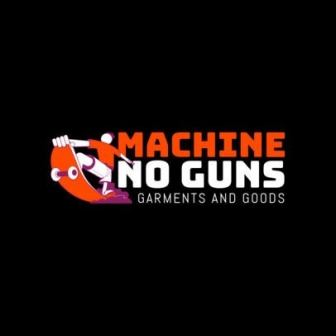Can you write a story inspired by this logo? In a bustling city where innovation and creativity thrived, a small shop called 'Machine No Guns' became a beacon of peace and positivity. The store, run by a passionate group of friends, offered unique garments and goods that carried messages of harmony and non-violence. Every product was crafted with care, from the dual-tone T-shirts featuring inspiring quotes to the eco-friendly accessories that promoted sustainable living. Customers who walked into the store were greeted by a lively mural of the cartoon character from the logo, now depicted playing a guitar in a sunlit park, surrounded by a joyful community. Over time, 'Machine No Guns' became more than just a store; it evolved into a movement, spreading the ethos of peace and creativity far beyond its walls. Artists, musicians, and activists found a common ground here, turning it into a cultural hub where the spirit of non-violence resonated in every corner. The company's logo, initially a simple design against a black backdrop, had transformed in the hearts and minds of the people, symbolizing a brighter, gun-free future. 